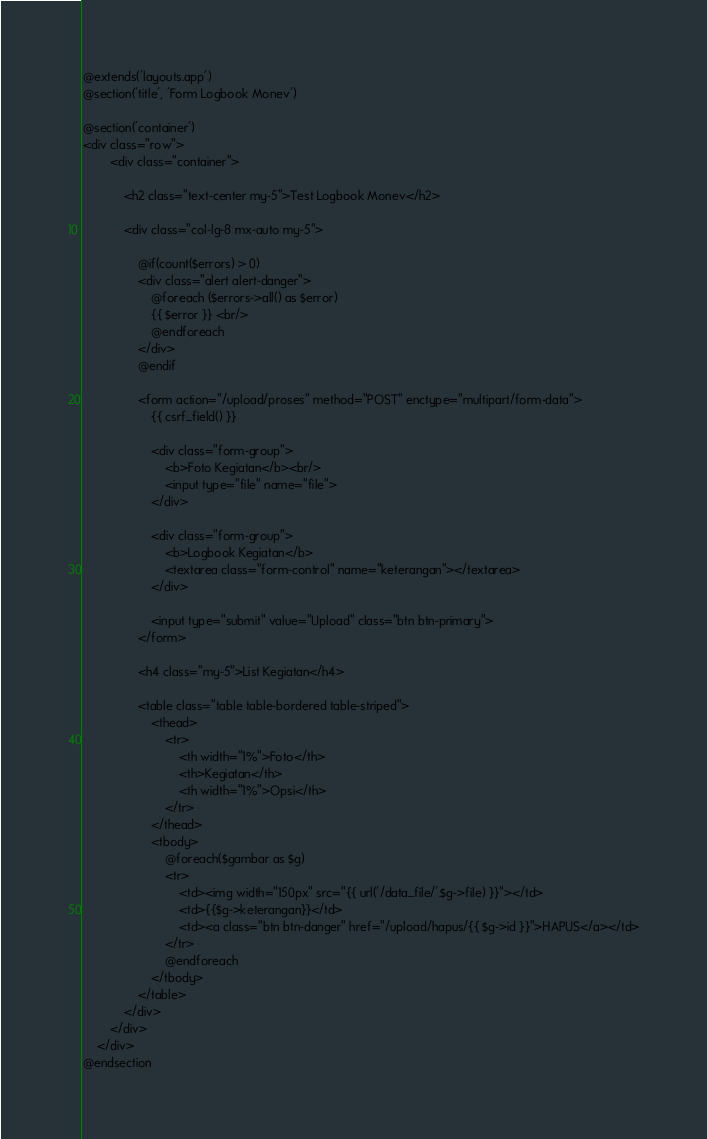<code> <loc_0><loc_0><loc_500><loc_500><_PHP_>@extends('layouts.app')
@section('title', 'Form Logbook Monev')

@section('container')
<div class="row">
		<div class="container">
 
			<h2 class="text-center my-5">Test Logbook Monev</h2>
			
			<div class="col-lg-8 mx-auto my-5">	
 
				@if(count($errors) > 0)
				<div class="alert alert-danger">
					@foreach ($errors->all() as $error)
					{{ $error }} <br/>
					@endforeach
				</div>
				@endif
 
				<form action="/upload/proses" method="POST" enctype="multipart/form-data">
					{{ csrf_field() }}
 
					<div class="form-group">
						<b>Foto Kegiatan</b><br/>
						<input type="file" name="file">
					</div>
 
					<div class="form-group">
						<b>Logbook Kegiatan</b>
						<textarea class="form-control" name="keterangan"></textarea>
					</div>
 
					<input type="submit" value="Upload" class="btn btn-primary">
				</form>
				
				<h4 class="my-5">List Kegiatan</h4>
 
				<table class="table table-bordered table-striped">
					<thead>
						<tr>
							<th width="1%">Foto</th>
							<th>Kegiatan</th>
							<th width="1%">Opsi</th>
						</tr>
					</thead>
					<tbody>
						@foreach($gambar as $g)
						<tr>
							<td><img width="150px" src="{{ url('/data_file/'.$g->file) }}"></td>
							<td>{{$g->keterangan}}</td>
							<td><a class="btn btn-danger" href="/upload/hapus/{{ $g->id }}">HAPUS</a></td>
						</tr>
						@endforeach
					</tbody>
				</table>
			</div>
		</div>
	</div>
@endsection</code> 